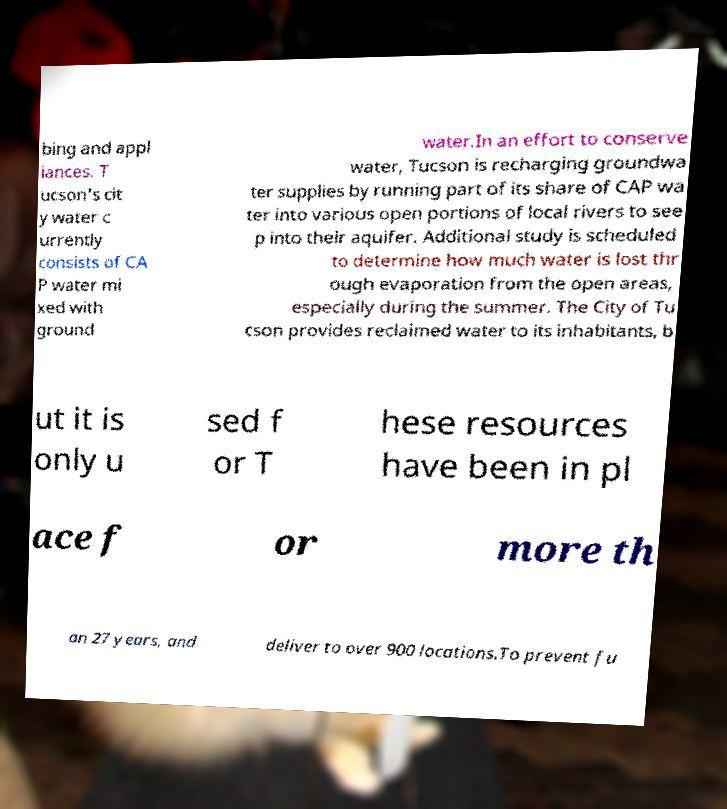Could you extract and type out the text from this image? bing and appl iances. T ucson's cit y water c urrently consists of CA P water mi xed with ground water.In an effort to conserve water, Tucson is recharging groundwa ter supplies by running part of its share of CAP wa ter into various open portions of local rivers to see p into their aquifer. Additional study is scheduled to determine how much water is lost thr ough evaporation from the open areas, especially during the summer. The City of Tu cson provides reclaimed water to its inhabitants, b ut it is only u sed f or T hese resources have been in pl ace f or more th an 27 years, and deliver to over 900 locations.To prevent fu 